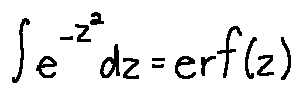<formula> <loc_0><loc_0><loc_500><loc_500>\int e ^ { - z ^ { 2 } } d z = e r f ( z )</formula> 